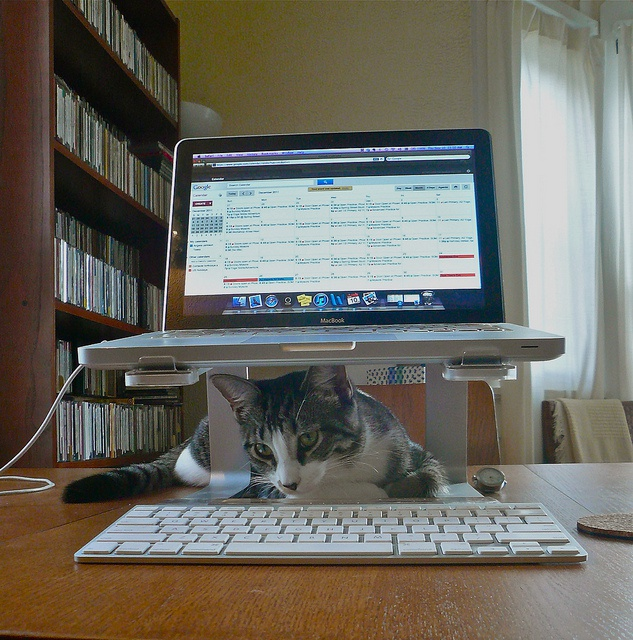Describe the objects in this image and their specific colors. I can see laptop in black, lightgray, gray, and lightblue tones, book in black, gray, maroon, and darkgreen tones, keyboard in black, darkgray, gray, and lightblue tones, cat in black, gray, and darkgray tones, and chair in black and gray tones in this image. 